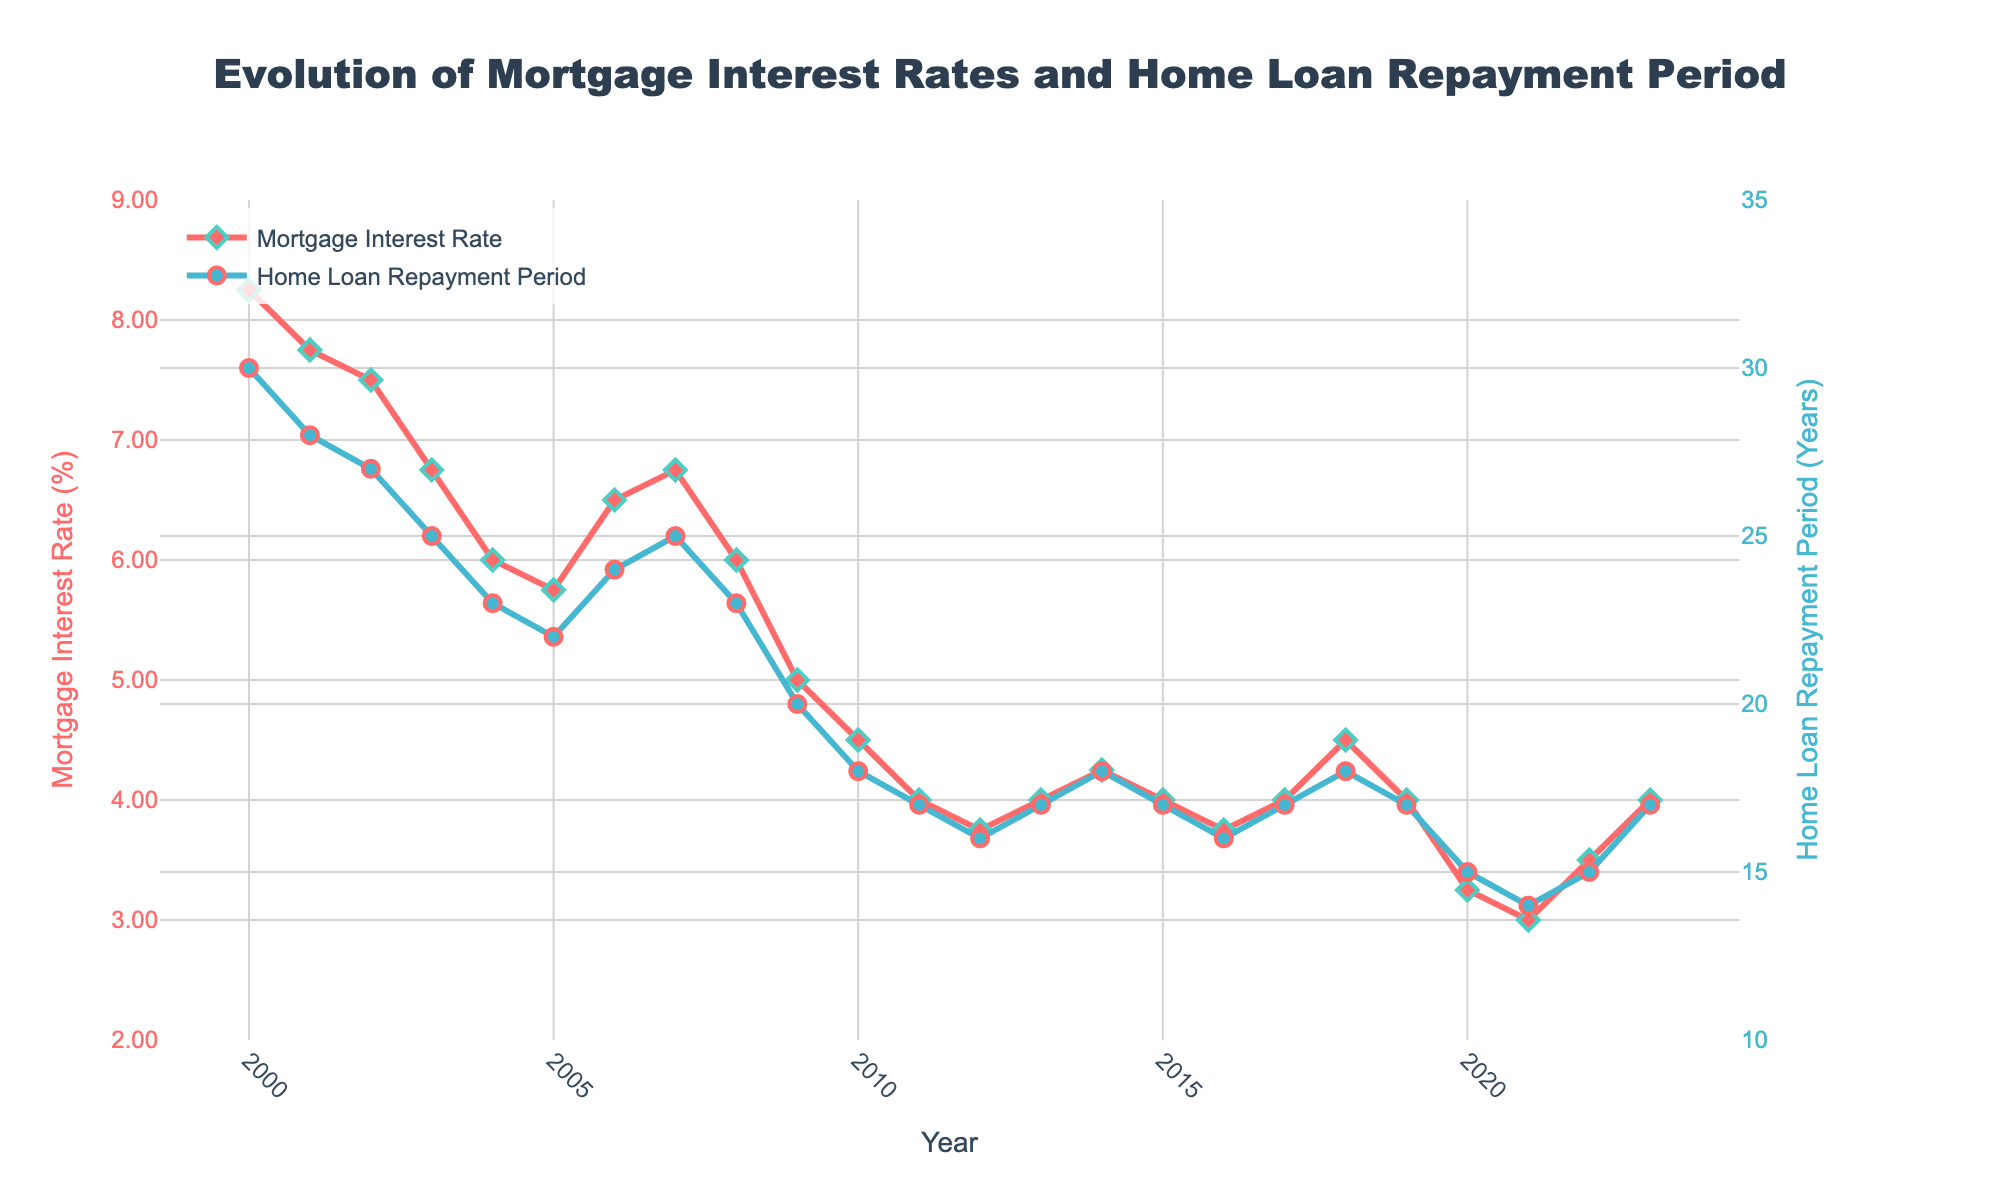What's the title of the figure? The title is prominently displayed at the top center of the figure. It reads, "Evolution of Mortgage Interest Rates and Home Loan Repayment Period".
Answer: Evolution of Mortgage Interest Rates and Home Loan Repayment Period How did the mortgage interest rate change from 2000 to 2023? By examining the line plot, the mortgage interest rate decreased from 8.25% in 2000 to 4.00% in 2023.
Answer: Decreased How many years show a mortgage interest rate below 4.00%? The years when the mortgage interest rate was below 4.00% are 2016 (3.75%), 2012 (3.75%), 2022 (3.50%), 2021 (3.00%), and 2020 (3.25%). There are 5 such years.
Answer: 5 Which year had the lowest home loan repayment period, and what was that period? The lowest home loan repayment period observed was 14 years in 2021, as shown by the blue line reaching its minimum.
Answer: 2021, 14 years In which year did both the mortgage interest rate and the home loan repayment period decrease? In 2021, both the mortgage interest rate dropped to 3.0% and the home loan repayment period decreased to 14 years simultaneously.
Answer: 2021 Compare the home loan repayment period for 2005 and 2023. By looking at the blue line, the repayment period was 22 years in 2005 and 17 years in 2023, a decrease of 5 years.
Answer: 22 years in 2005, 17 years in 2023 What was the approximate average mortgage interest rate over the span of the chart? By adding up all the mortgage interest rates from 2000 to 2023 and dividing by the number of years (24), the approximate average is found. The sum is roughly 134.00% and the average is about 5.58%.
Answer: 5.58% Did the mortgage interest rate peak more than once between 2000 and 2023? Yes, the mortgage interest rate reached peaks around 2000 (8.25%) and again around 2006-2007 (6.50%-6.75%).
Answer: Yes If a homebuyer took a loan in 2009 and another in 2020, how many years shorter was the repayment period in 2020 compared to 2009? The repayment period in 2009 was 20 years, and in 2020 it was 15 years. The difference is 5 years.
Answer: 5 years Was there a year where the mortgage interest rate was constant but the home loan repayment period varied significantly? Yes, in 2017, 2015, and 2013, the mortgage interest rate was constant at 4.00% but the repayment periods varied between 16 and 18 years. This indicates variations in the repayment periods despite stable interest rates.
Answer: Yes 